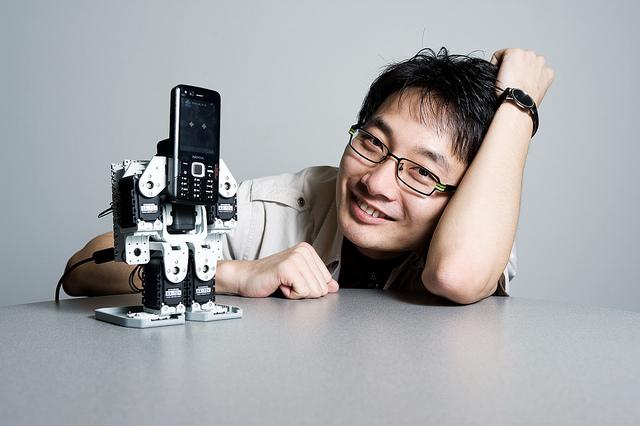What is holding the cell phone?
Give a very brief answer. Robot. Who is wearing glasses?
Quick response, please. Man. Is the man wearing watch?
Keep it brief. Yes. 